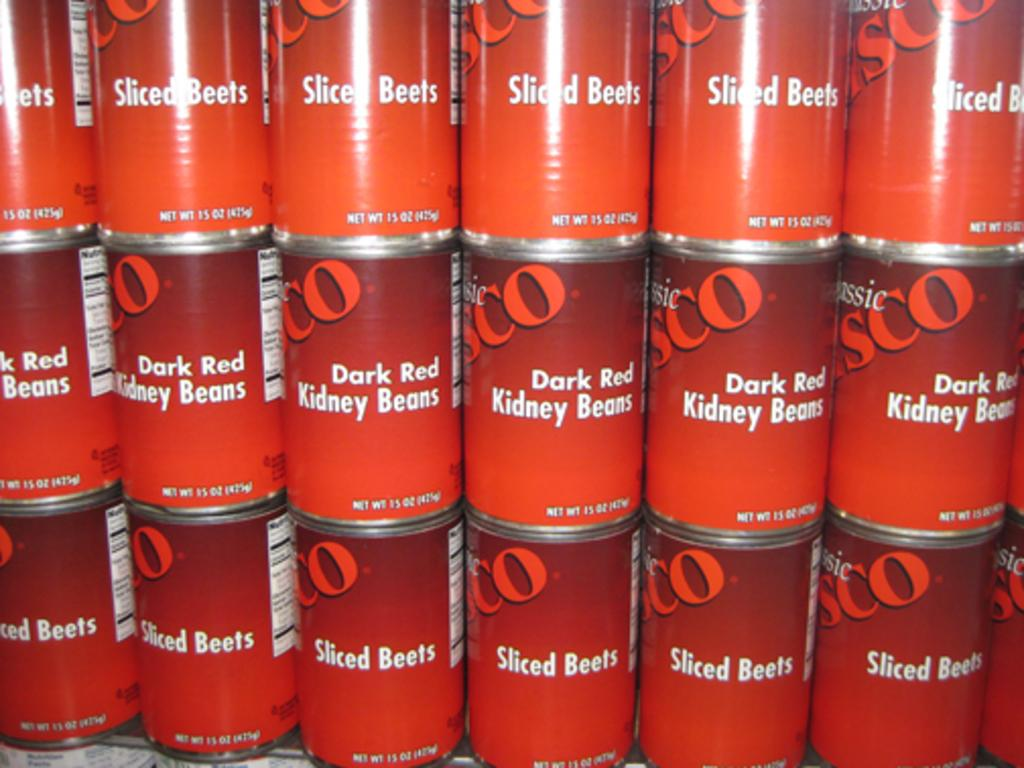Provide a one-sentence caption for the provided image. Cans of Sliced Beets and Dark Red Kidney Beans. 